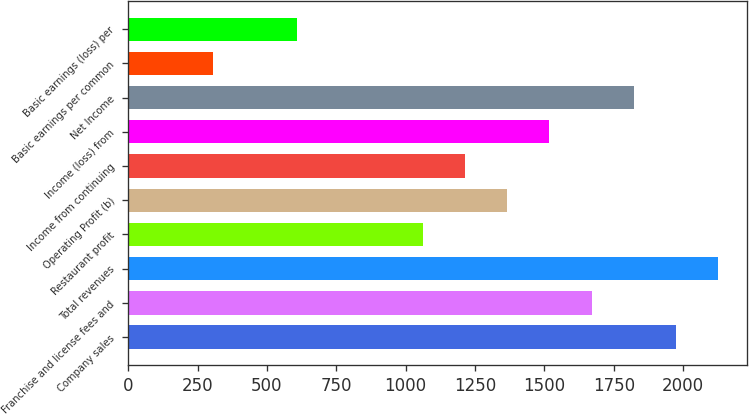Convert chart to OTSL. <chart><loc_0><loc_0><loc_500><loc_500><bar_chart><fcel>Company sales<fcel>Franchise and license fees and<fcel>Total revenues<fcel>Restaurant profit<fcel>Operating Profit (b)<fcel>Income from continuing<fcel>Income (loss) from<fcel>Net Income<fcel>Basic earnings per common<fcel>Basic earnings (loss) per<nl><fcel>1973.26<fcel>1669.76<fcel>2125.01<fcel>1062.76<fcel>1366.26<fcel>1214.51<fcel>1518.01<fcel>1821.51<fcel>304.01<fcel>607.51<nl></chart> 